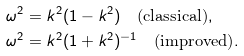<formula> <loc_0><loc_0><loc_500><loc_500>\omega ^ { 2 } & = k ^ { 2 } ( 1 - k ^ { 2 } ) \quad \text {(classical)} , \\ \omega ^ { 2 } & = k ^ { 2 } ( 1 + k ^ { 2 } ) ^ { - 1 } \quad \text {(improved)} . \\</formula> 